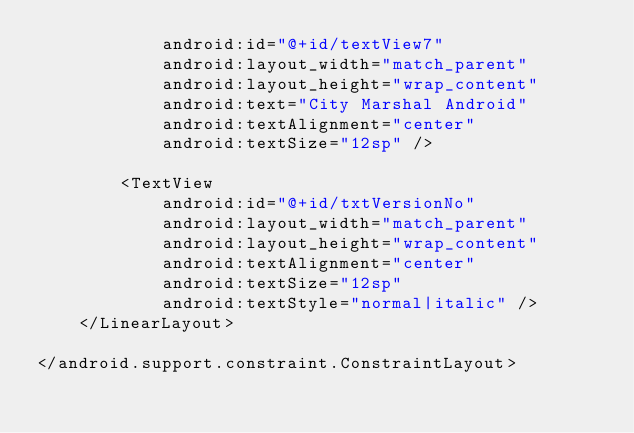<code> <loc_0><loc_0><loc_500><loc_500><_XML_>            android:id="@+id/textView7"
            android:layout_width="match_parent"
            android:layout_height="wrap_content"
            android:text="City Marshal Android"
            android:textAlignment="center"
            android:textSize="12sp" />

        <TextView
            android:id="@+id/txtVersionNo"
            android:layout_width="match_parent"
            android:layout_height="wrap_content"
            android:textAlignment="center"
            android:textSize="12sp"
            android:textStyle="normal|italic" />
    </LinearLayout>

</android.support.constraint.ConstraintLayout>
</code> 